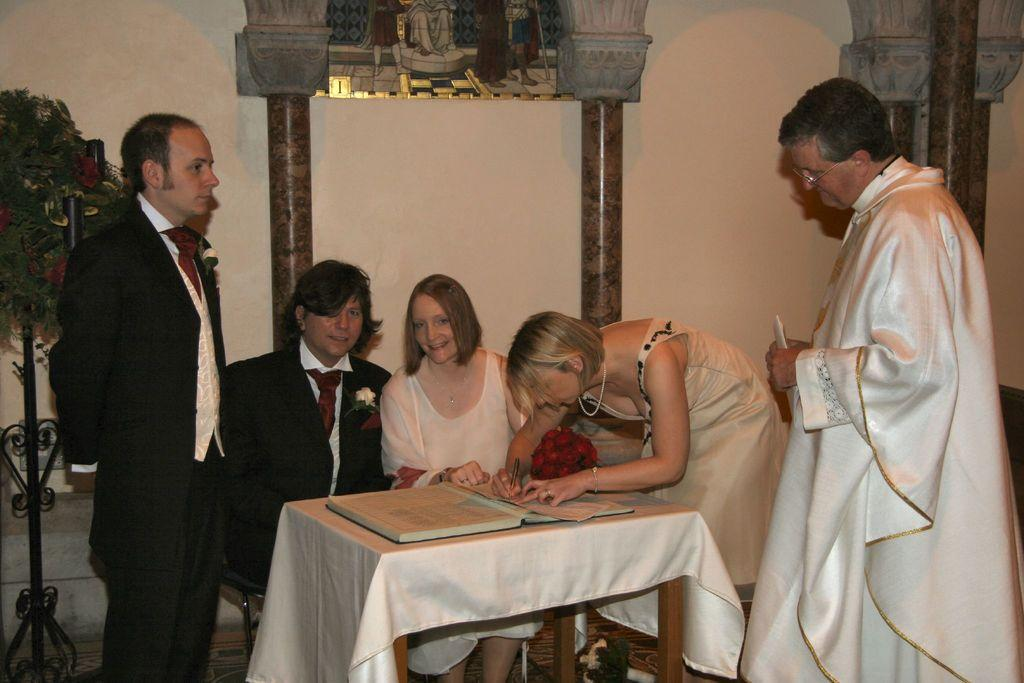What are the couple in the image doing? The couple is seated on chairs in the image. How many people are standing in the image? There are three people standing in the image. What is the woman in the image doing? The woman is writing on a paper in the image. What type of sheet is being used to support the pin in the image? There is no sheet or pin present in the image. What scientific theory is being discussed by the people in the image? The image does not depict any scientific theories being discussed. 